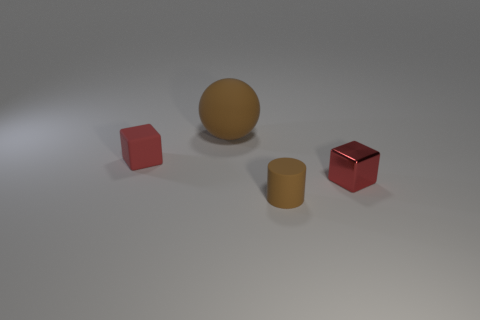Can you describe the colors present in this image? Certainly. The image showcases objects in matte finishes of red, yellow, and a neutral color that resembles beige or light brown.  Are the objects arranged in any particular pattern? The objects are arranged with some spacing between them on a flat surface, but there does not appear to be a specific pattern. The arrangement seems random. 